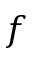Convert formula to latex. <formula><loc_0><loc_0><loc_500><loc_500>f</formula> 